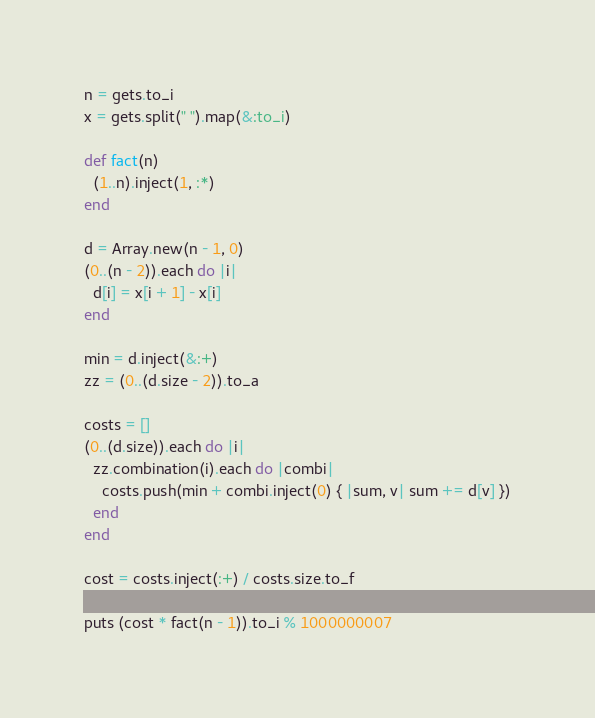Convert code to text. <code><loc_0><loc_0><loc_500><loc_500><_Ruby_>n = gets.to_i
x = gets.split(" ").map(&:to_i)

def fact(n)
  (1..n).inject(1, :*)
end

d = Array.new(n - 1, 0)
(0..(n - 2)).each do |i|
  d[i] = x[i + 1] - x[i]
end

min = d.inject(&:+)
zz = (0..(d.size - 2)).to_a

costs = []
(0..(d.size)).each do |i|
  zz.combination(i).each do |combi|
    costs.push(min + combi.inject(0) { |sum, v| sum += d[v] })
  end
end

cost = costs.inject(:+) / costs.size.to_f

puts (cost * fact(n - 1)).to_i % 1000000007</code> 